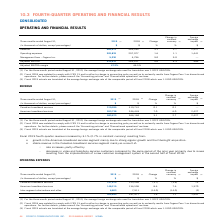According to Cogeco's financial document, What was the exchange rate for the three-month period ended August 31, 2019? According to the financial document, 1.3222 USD/CDN. The relevant text states: "ge foreign exchange rate used for translation was 1.3222 USD/CDN...." Also, What was the exchange rate for the three-month period ended august 2018? According to the financial document, 1.3100 USD/CDN. The relevant text states: "of the comparable period of fiscal 2018 which was 1.3100 USD/CDN...." Also, What was the increase in the operating expenses in 2019 fourth-quarter fiscal year? Based on the financial document, the answer is 1.6%. Also, can you calculate: What was the increase / (decrease) in the Canadian broadband services from three months ended August 31, 2018 to 2019? Based on the calculation: 147,815 - 153,560, the result is -5745 (in thousands). This is based on the information: "Canadian broadband services 147,815 153,560 (3.7) (3.8) 73 Canadian broadband services 147,815 153,560 (3.7) (3.8) 73..." The key data points involved are: 147,815, 153,560. Also, can you calculate: What was the average American broadband services from three months ended August 31, 2018 to 2019? To answer this question, I need to perform calculations using the financial data. The calculation is: (148,215 + 136,506) / 2, which equals 142360.5 (in thousands). This is based on the information: "American broadband services 148,215 136,506 8.6 7.6 1,370 American broadband services 148,215 136,506 8.6 7.6 1,370..." The key data points involved are: 136,506, 148,215. Also, can you calculate: What was the increase / (decrease) in the Inter-segment eliminations and other from three months ended August 31, 2018 to 2019? Based on the calculation: 6,803 - 7,911, the result is -1108 (in thousands). This is based on the information: "Inter-segment eliminations and other 6,803 7,911 (14.0) (14.0) (2) Inter-segment eliminations and other 6,803 7,911 (14.0) (14.0) (2)..." The key data points involved are: 6,803, 7,911. 